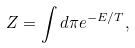<formula> <loc_0><loc_0><loc_500><loc_500>Z = \int d \pi e ^ { - E / T } ,</formula> 